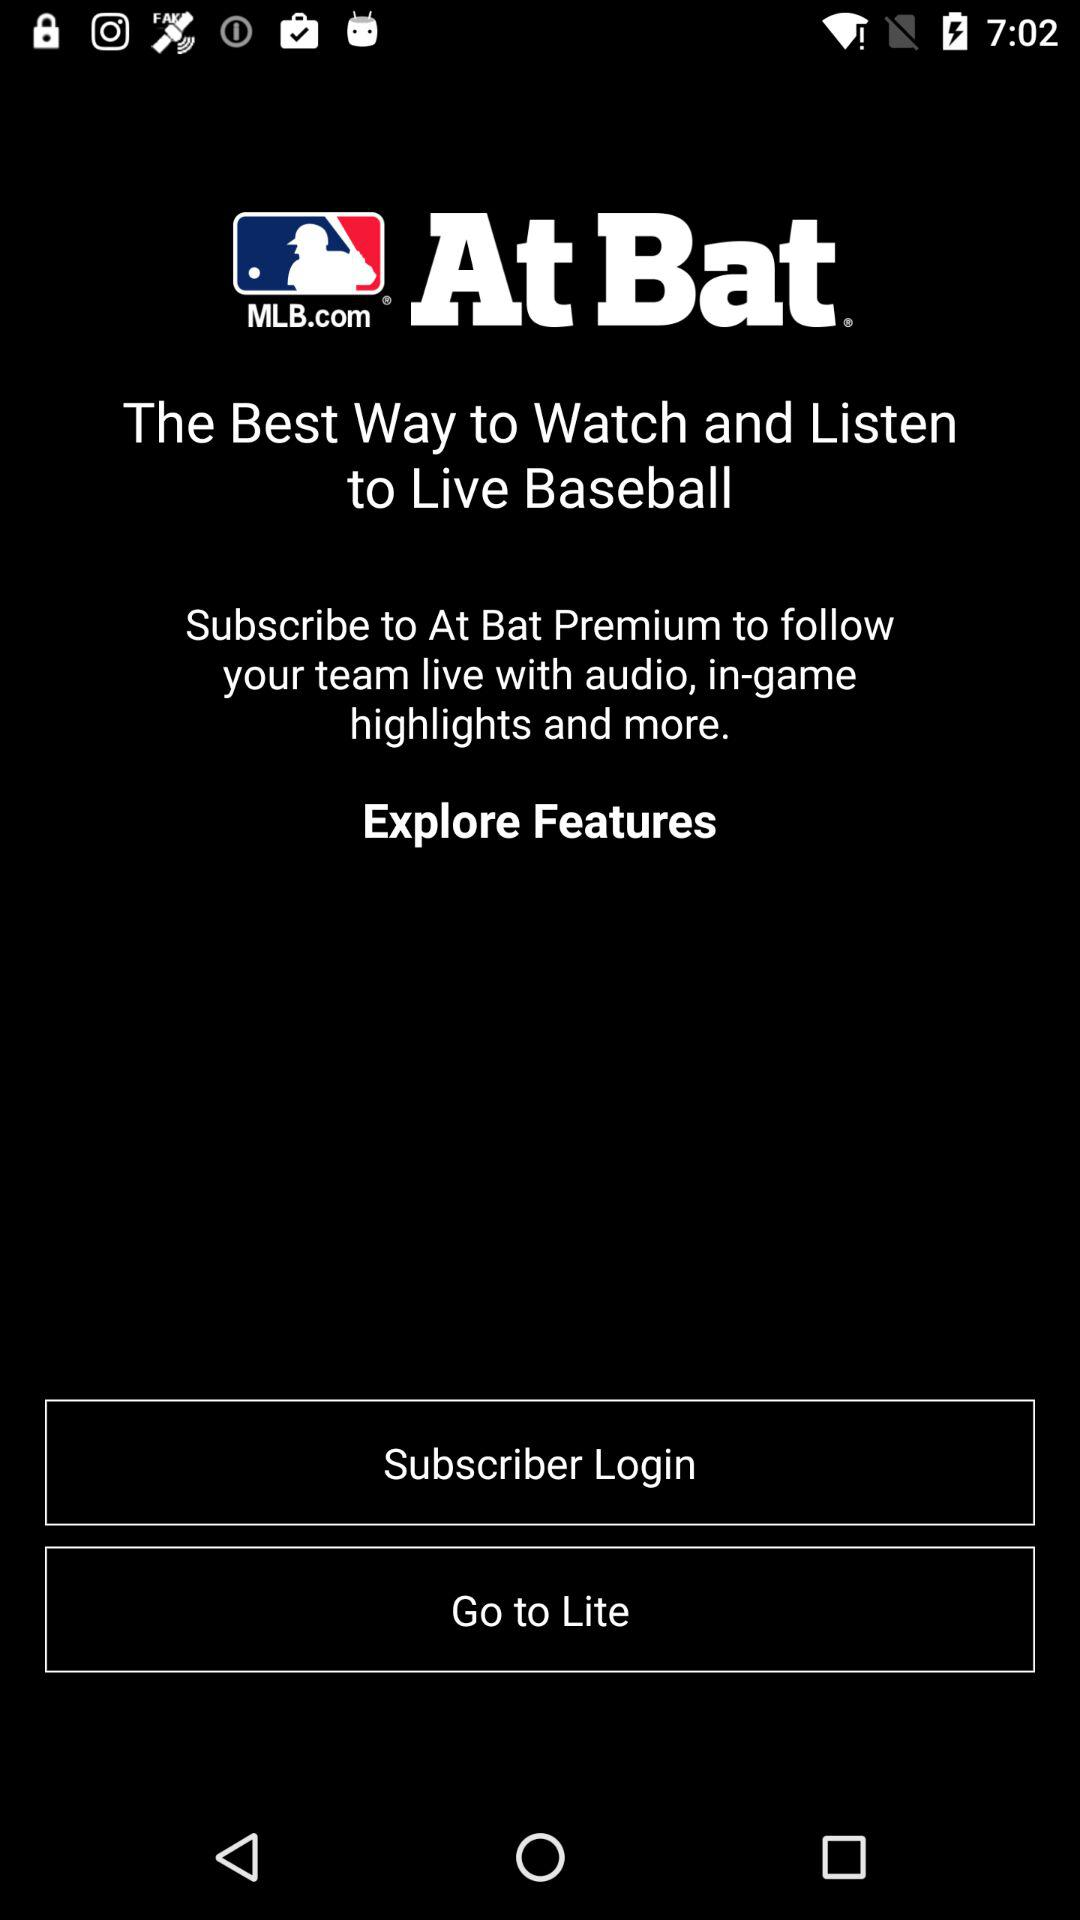What is the name of the application? The name of the application is "MLB.com At Bat". 